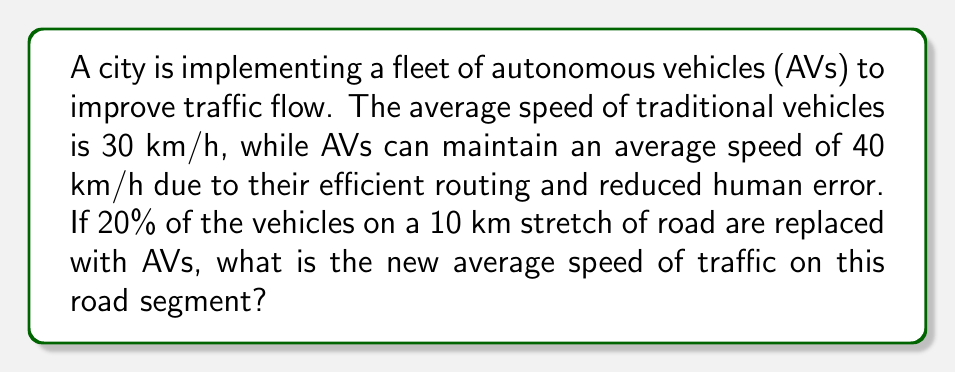Solve this math problem. To solve this problem, we need to use the concept of weighted average. Let's break it down step-by-step:

1. Define variables:
   $v_t$ = speed of traditional vehicles = 30 km/h
   $v_a$ = speed of autonomous vehicles = 40 km/h
   $p_a$ = proportion of autonomous vehicles = 20% = 0.2
   $p_t$ = proportion of traditional vehicles = 1 - $p_a$ = 0.8

2. The weighted average speed ($v_{avg}$) is calculated using the formula:
   $$v_{avg} = p_t \cdot v_t + p_a \cdot v_a$$

3. Substitute the values:
   $$v_{avg} = 0.8 \cdot 30 + 0.2 \cdot 40$$

4. Calculate:
   $$v_{avg} = 24 + 8 = 32$$

Therefore, the new average speed of traffic on this road segment is 32 km/h.
Answer: 32 km/h 